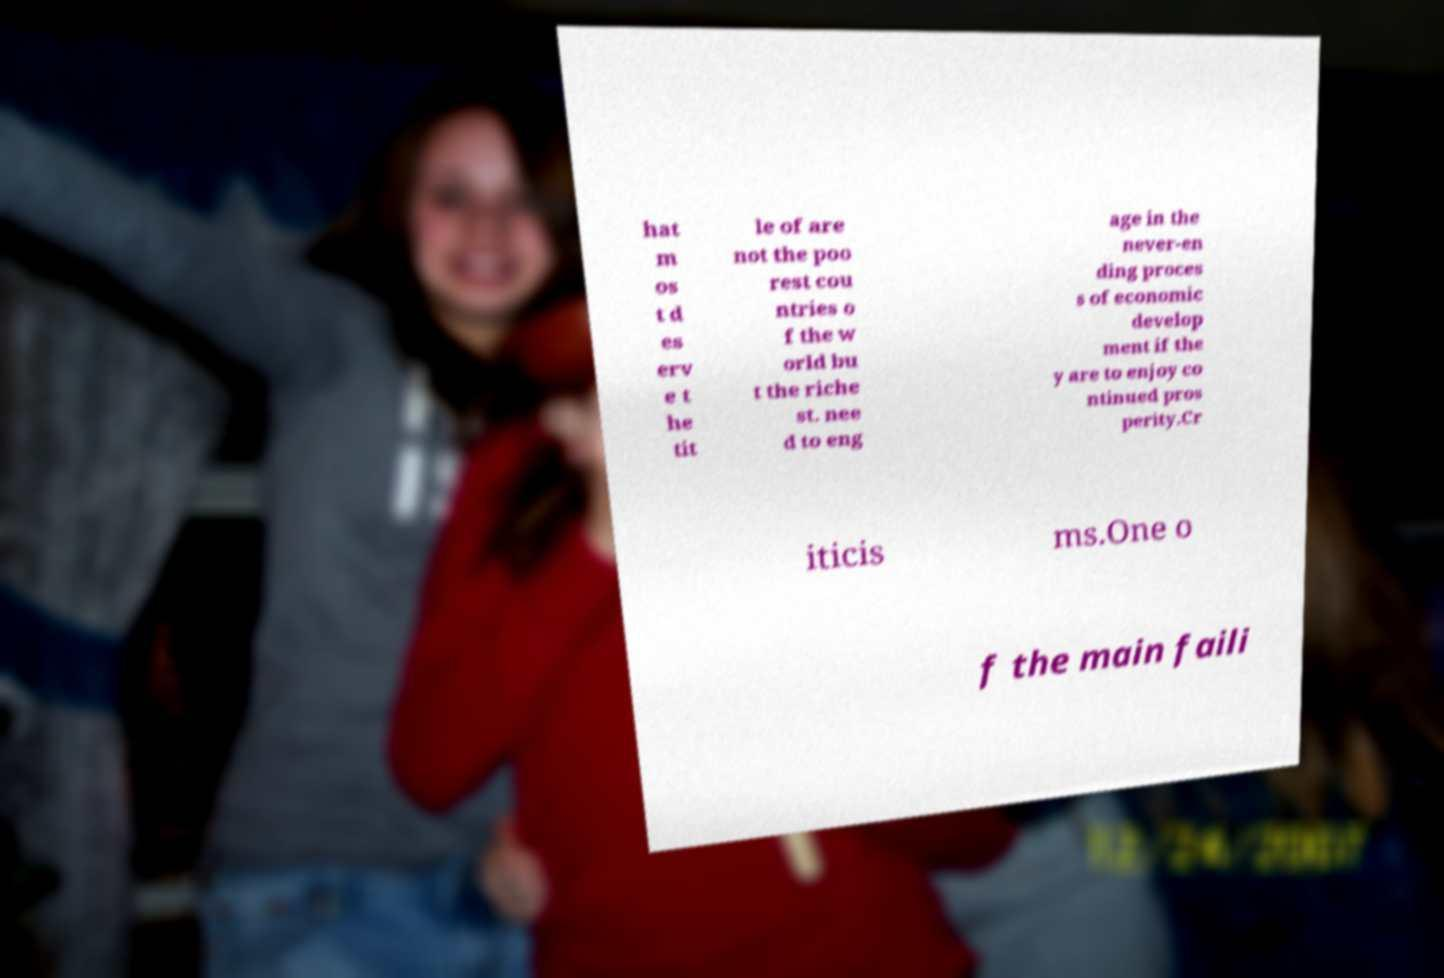Can you accurately transcribe the text from the provided image for me? hat m os t d es erv e t he tit le of are not the poo rest cou ntries o f the w orld bu t the riche st. nee d to eng age in the never-en ding proces s of economic develop ment if the y are to enjoy co ntinued pros perity.Cr iticis ms.One o f the main faili 